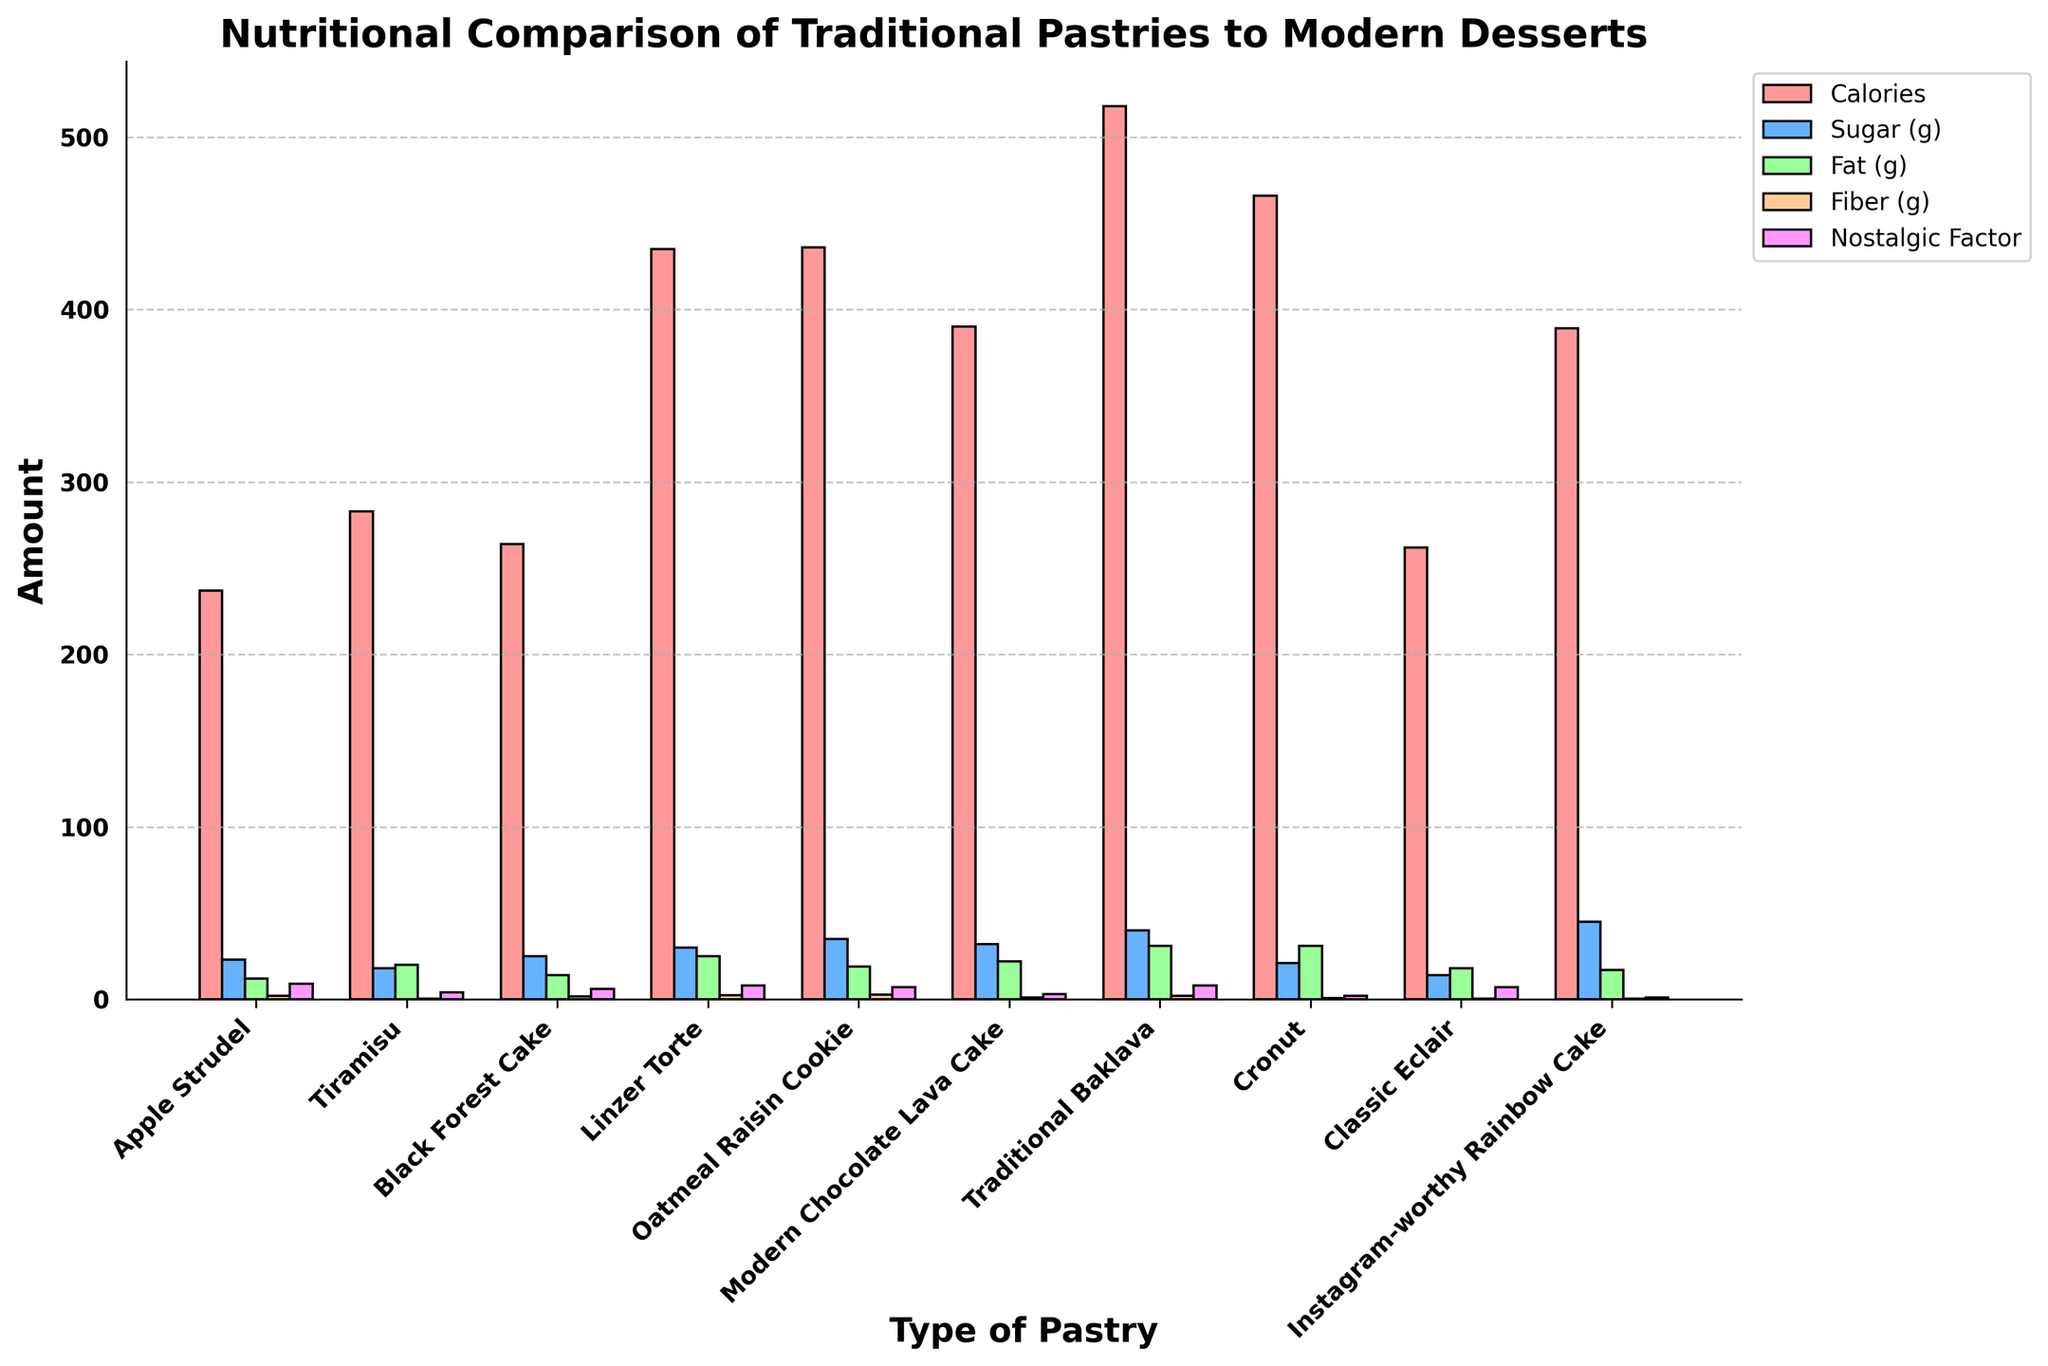Which pastry has the highest nostalgic factor? The nostalgic factor is shown by the pink bars. The highest bar in pink corresponds to Apple Strudel.
Answer: Apple Strudel Which dessert has the most sugar per 100g? The amount of sugar is represented by the blue bars. The tallest blue bar is for the Instagram-worthy Rainbow Cake.
Answer: Instagram-worthy Rainbow Cake What is the difference in calories between Linzer Torte and Cronut? To find the difference in calories, look at the red bars for Linzer Torte and Cronut. Linzer Torte has 435 calories while Cronut has 466 calories. The difference is 466 - 435 = 31.
Answer: 31 Which pastry is highest in fiber and what is its amount? The amount of fiber is shown by the beige bars. The tallest beige bar corresponds to Oatmeal Raisin Cookie with a fiber amount of 2.6g.
Answer: Oatmeal Raisin Cookie, 2.6g How does the fat content of Tiramisu compare to Apple Strudel? The fat content is represented by the green bars. Tiramisu has 20 grams of fat, while Apple Strudel has 12 grams. Therefore, Tiramisu has more fat.
Answer: Tiramisu has more fat Which pastries have a nostalgic factor higher than 6? The nostalgic factor is indicated by the pink bars. Pastries with bars taller than 6 are Apple Strudel, Linzer Torte, Oatmeal Raisin Cookie, Traditional Baklava, and Classic Eclair.
Answer: Apple Strudel, Linzer Torte, Oatmeal Raisin Cookie, Traditional Baklava, Classic Eclair What’s the average sugar content of the top three pastries highest in calories? The top three pastries highest in calories are Traditional Baklava (518), Cronut (466), and Oatmeal Raisin Cookie (436). Their sugar contents are 40g, 21g, and 35g respectively. The average sugar content is (40 + 21 + 35) / 3 = 96 / 3 = 32.
Answer: 32 If you combine the fiber content of Black Forest Cake and Linzer Torte, is it more than the fiber in Oatmeal Raisin Cookie? Black Forest Cake has 1.8g and Linzer Torte has 2.5g, summing up to 1.8 + 2.5 = 4.3g. Oatmeal Raisin Cookie has 2.6g of fiber. 4.3g is more than 2.6g.
Answer: Yes Which dessert has the lowest fat content? The fat content is shown by the green bars. The lowest green bar corresponds to Classic Eclair with 18g of fat.
Answer: Classic Eclair How does the nostalgic factor of Modern Chocolate Lava Cake compare to Traditional Baklava? The nostalgic factor is indicated by the pink bars. Modern Chocolate Lava Cake has a nostalgic factor of 3, while Traditional Baklava has a nostalgic factor of 8. Traditional Baklava has a higher nostalgic factor.
Answer: Traditional Baklava has a higher nostalgic factor 